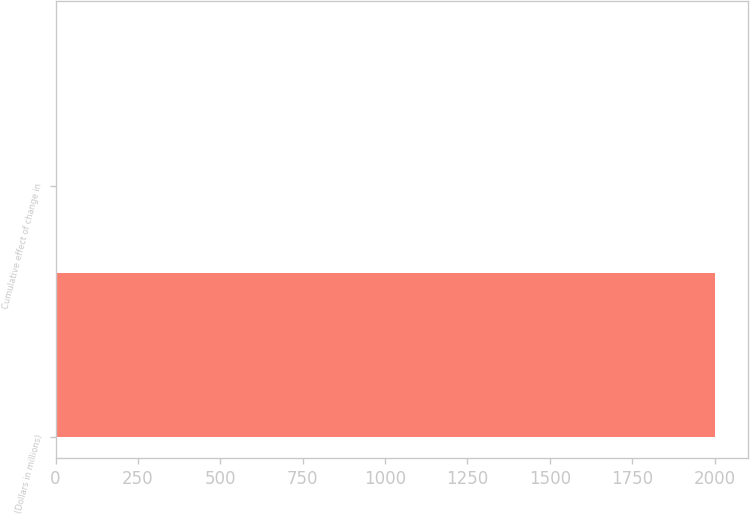Convert chart to OTSL. <chart><loc_0><loc_0><loc_500><loc_500><bar_chart><fcel>(Dollars in millions)<fcel>Cumulative effect of change in<nl><fcel>2003<fcel>3<nl></chart> 